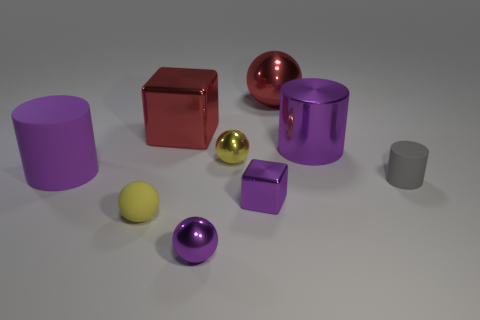Are there any other big spheres made of the same material as the red ball? Based on the image, while there appear to be several spheres, the only other large sphere besides the red one is purple. It's not possible to conclusively determine if they're made of the same material solely from the image, as material properties such as texture and makeup aren't visually discernible. However, they do share a reflective quality suggesting a similar polished finish. 